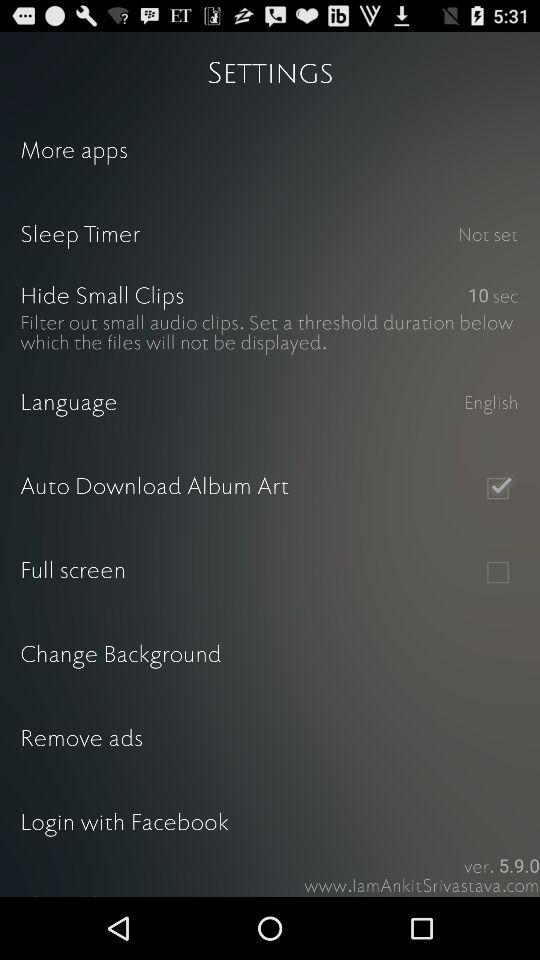What is the selected language? The selected language is English. 